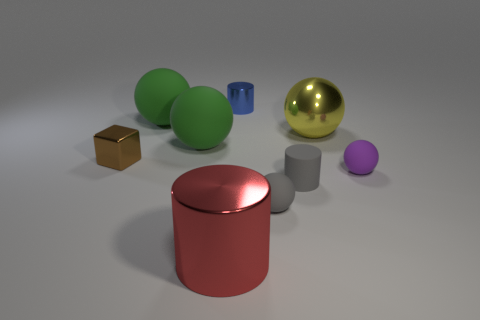Subtract all small purple rubber balls. How many balls are left? 4 Subtract all purple cylinders. How many green spheres are left? 2 Subtract all green spheres. How many spheres are left? 3 Add 1 yellow blocks. How many objects exist? 10 Subtract all cubes. How many objects are left? 8 Add 6 tiny rubber cylinders. How many tiny rubber cylinders are left? 7 Add 1 tiny green rubber cubes. How many tiny green rubber cubes exist? 1 Subtract 1 blue cylinders. How many objects are left? 8 Subtract all yellow cylinders. Subtract all brown balls. How many cylinders are left? 3 Subtract all large gray things. Subtract all yellow things. How many objects are left? 8 